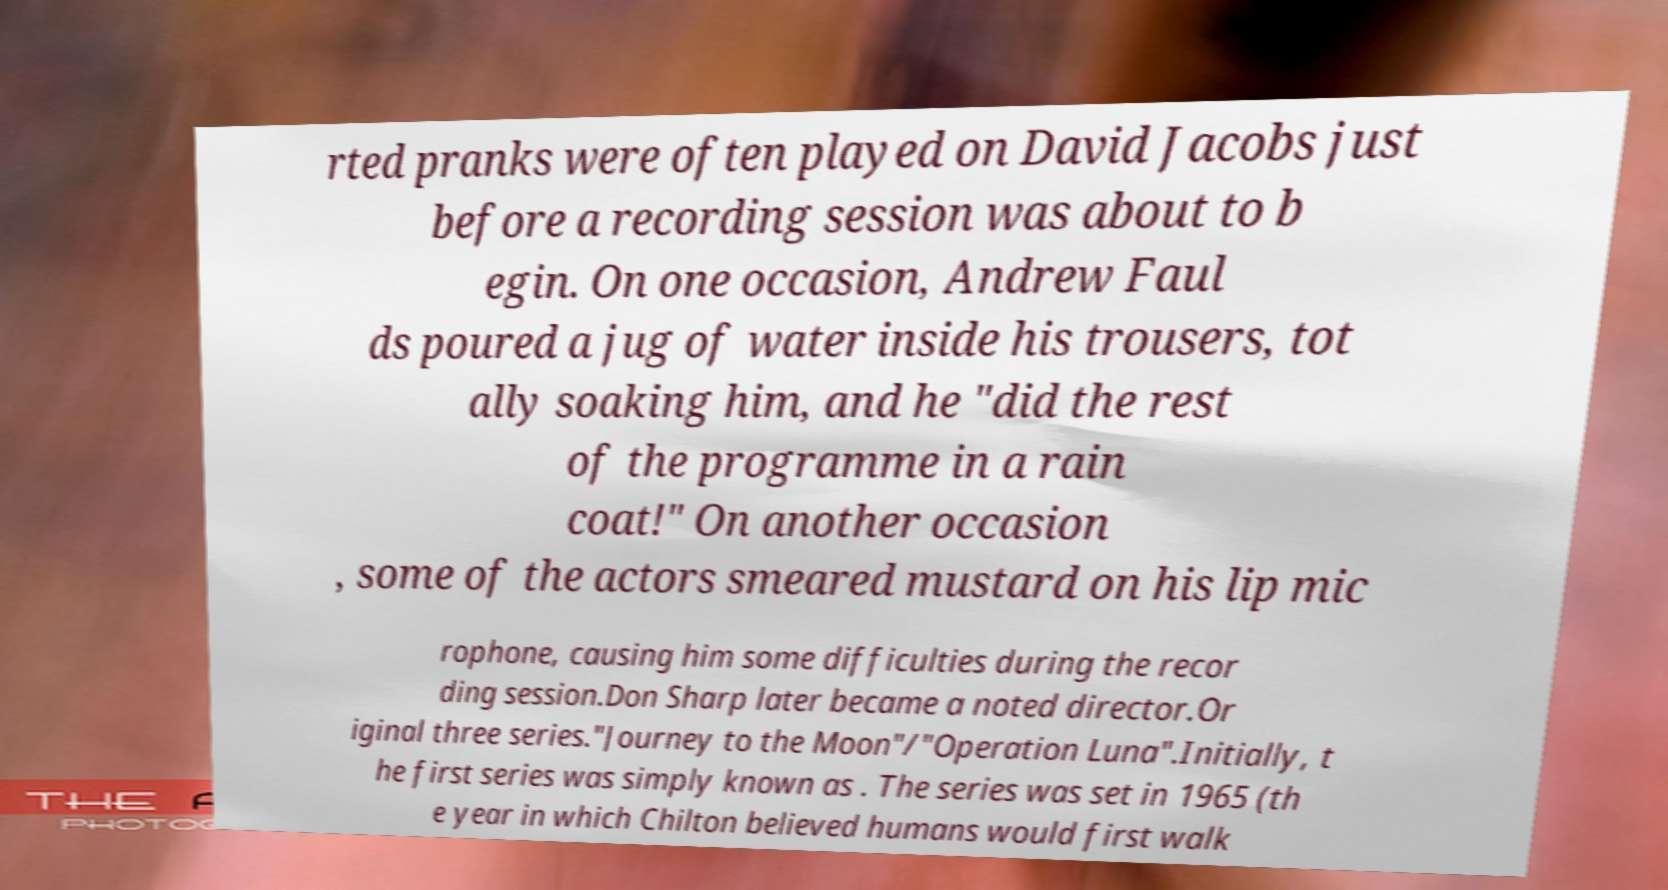Please read and relay the text visible in this image. What does it say? rted pranks were often played on David Jacobs just before a recording session was about to b egin. On one occasion, Andrew Faul ds poured a jug of water inside his trousers, tot ally soaking him, and he "did the rest of the programme in a rain coat!" On another occasion , some of the actors smeared mustard on his lip mic rophone, causing him some difficulties during the recor ding session.Don Sharp later became a noted director.Or iginal three series."Journey to the Moon"/"Operation Luna".Initially, t he first series was simply known as . The series was set in 1965 (th e year in which Chilton believed humans would first walk 